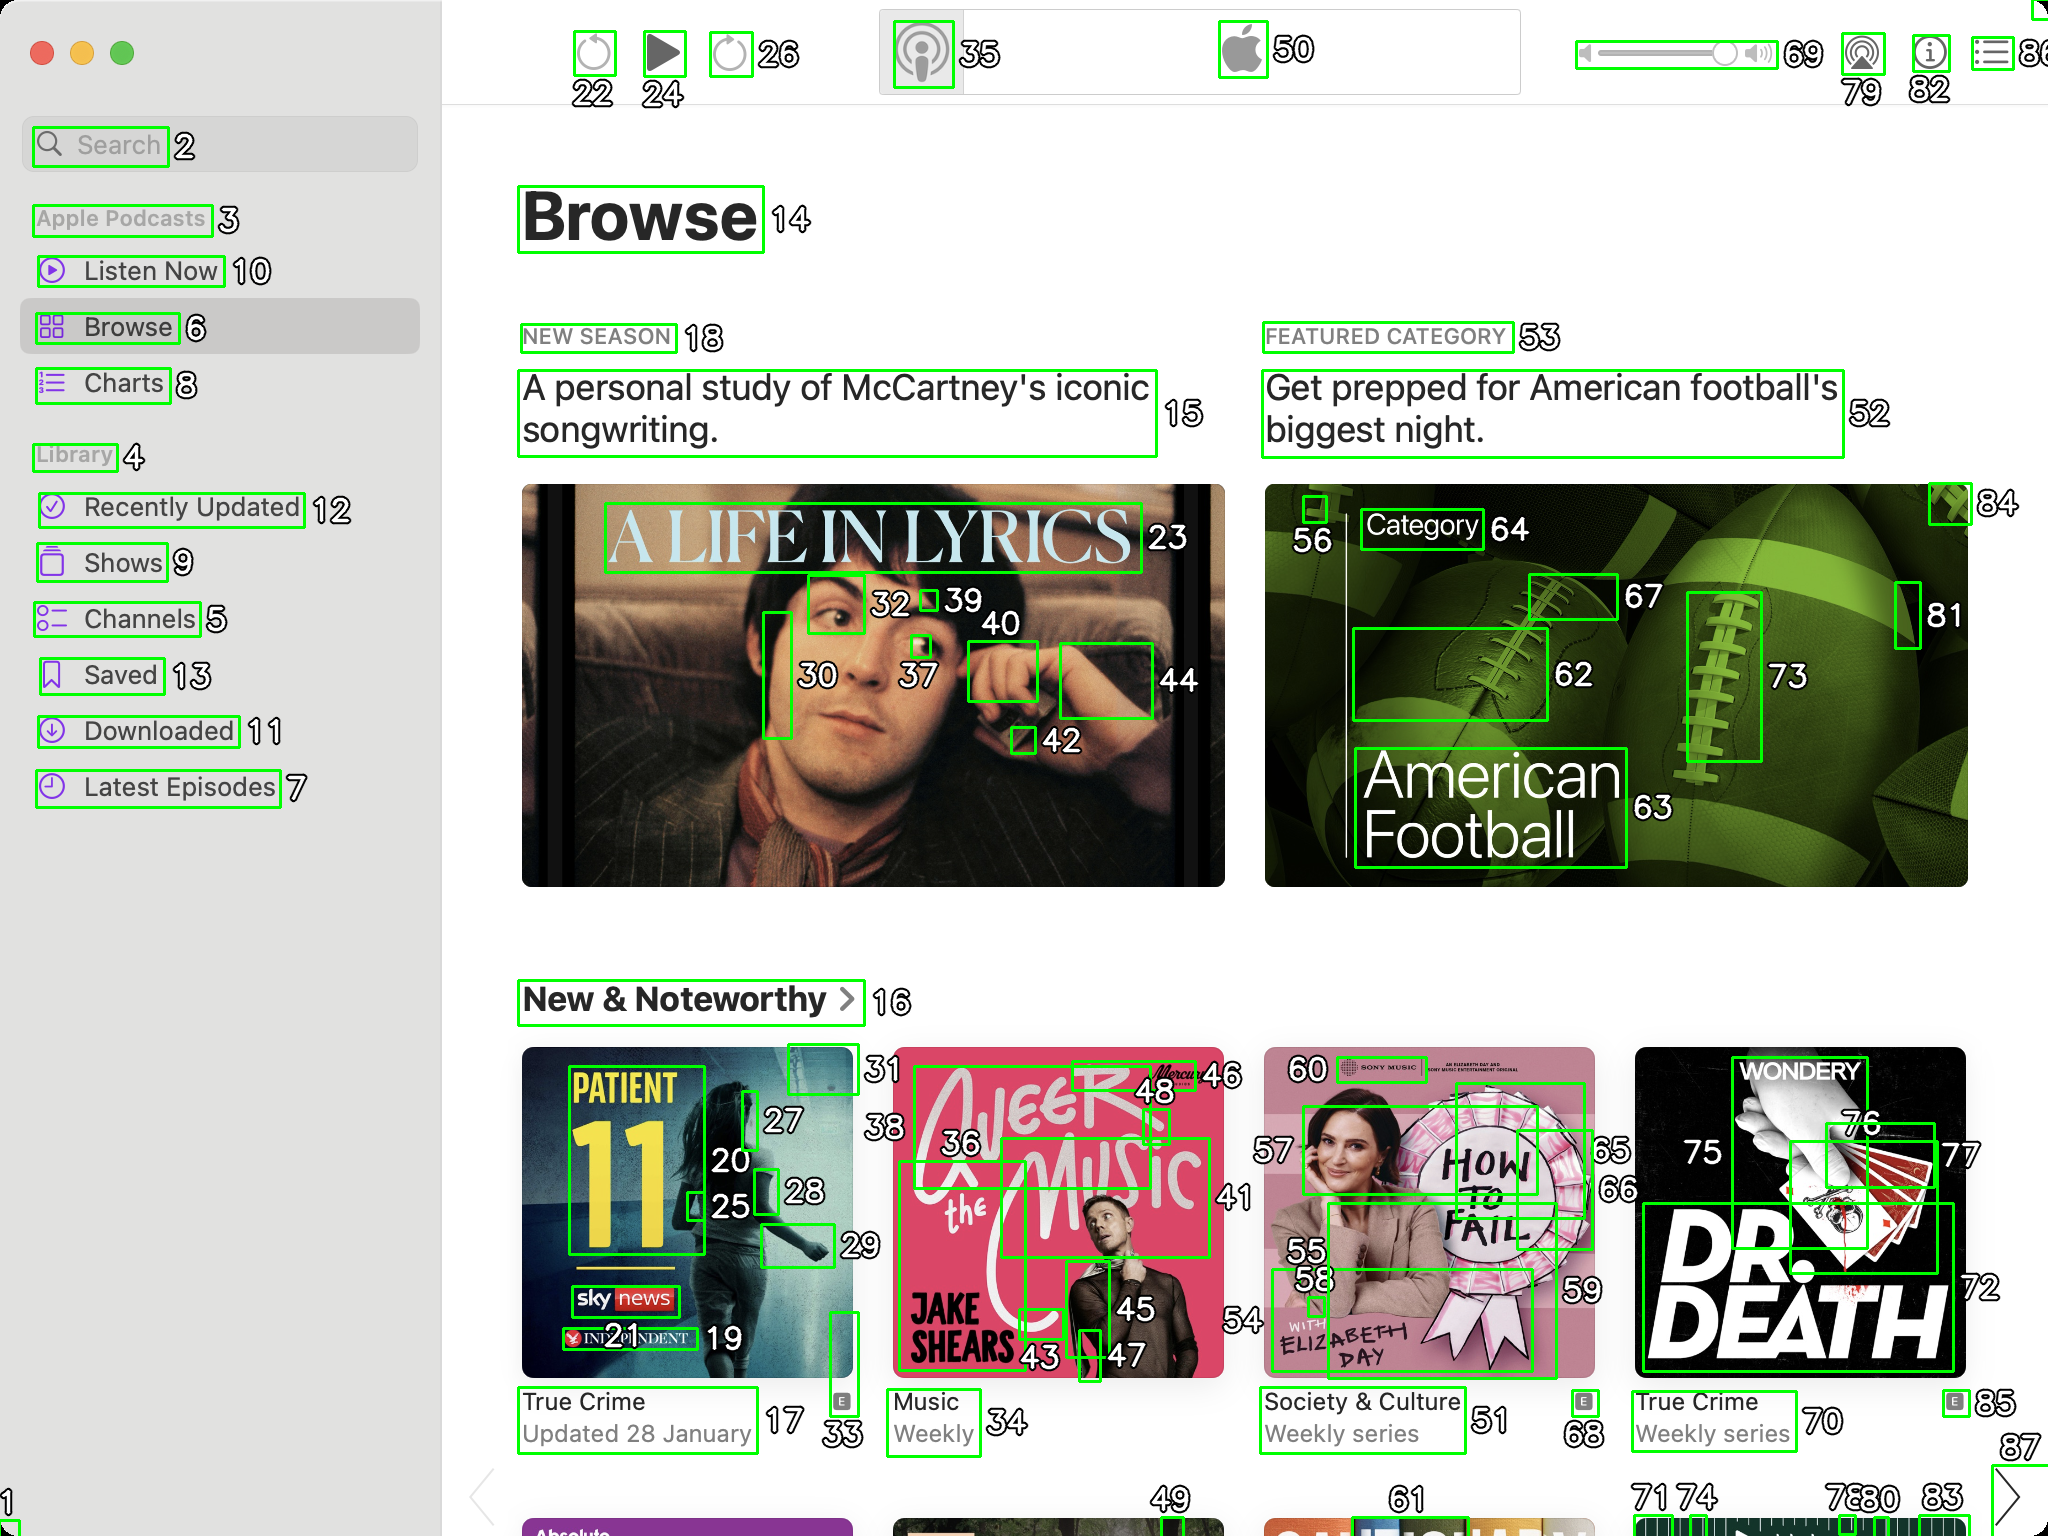You are an AI designed for image processing and segmentation analysis, particularly skilled in merging segmented regions of an image to improve accuracy and readability.

**Task Description:**
Your task is to address a user's concern with a UI screenshot of the Apple Podcasts application on MacOS. The screenshot contains multiple green boxes, each representing a UI element, with a unique white number outlined in black ranging from 1 to 88. Due to segmentation issues, some boxes that belong to the same image are divided unnaturally.

**Objective:**
Merge these segmented areas that correspond to a single UI element to create a coherent representation. The final output should be in JSON format, where each key-value pair represents the merged areas.

**Example JSON Output:**
If boxes with numbers 1, 2, and 3 should belong to the same UI element, the JSON output should be:

```json
{
    "Image A Life In Lyrics": [1, 2, 3]
}
```

**Instructions:**

- **Identify Segmented Regions:** Analyze the screenshot to identify which green boxes belong to the same UI element.
- **Merge Regions:** Group the numbers of these boxes together to represent a single UI element.
- **Output Format:** Produce the output in JSON format, with each key representing a UI element and each value being a list of the numbers of the merged boxes.

**Primary Objective:**
Ensure the accuracy of the merged regions based on the user's supplied image information, maintaining the integrity and structure of the UI elements in the Apple Podcasts application on MacOS. Based on the provided screenshot, I have identified the segmented regions that belong to the same UI elements. Here is the JSON output representing the merged areas:

```json
{
    "Search": [2],
    "Apple Podcasts": [3],
    "Listen Now": [10],
    "Browse": [6, 14],
    "Charts": [8],
    "Library": [4],
    "Recently Updated": [12],
    "Shows": [9],
    "Channels": [5],
    "Saved": [13],
    "Downloaded": [11],
    "Latest Episodes": [7],
    "A Life In Lyrics": [15, 23, 30, 32, 37, 39, 40, 42, 44],
    "New Season": [18],
    "Featured Category": [53],
    "Get prepped for American football's biggest night.": [52, 56, 62, 63, 64, 67, 73, 81, 84],
    "New & Noteworthy": [16],
    "Patient 11": [17, 20, 25, 27, 28, 33],
    "True Crime": [17],
    "Updated 28 January": [17],
    "A Beer with the Music": [36, 43, 45, 46, 48],
    "Weekly": [36],
    "How to Fail": [55, 58, 59, 60],
    "Society & Culture": [51],
    "Weekly series": [51],
    "Dr. Death": [70, 72, 75, 76, 77],
    "True Crime": [70],
    "Weekly series": [70],
    "Apple Logo": [50],
    "Play Button": [24],
    "Volume Control": [69, 79, 82],
    "Settings": [35],
    "Other": [22, 26, 85]
}
```

This JSON output groups the segmented boxes into their respective UI elements, ensuring a coherent representation of the Apple Podcasts application interface. 